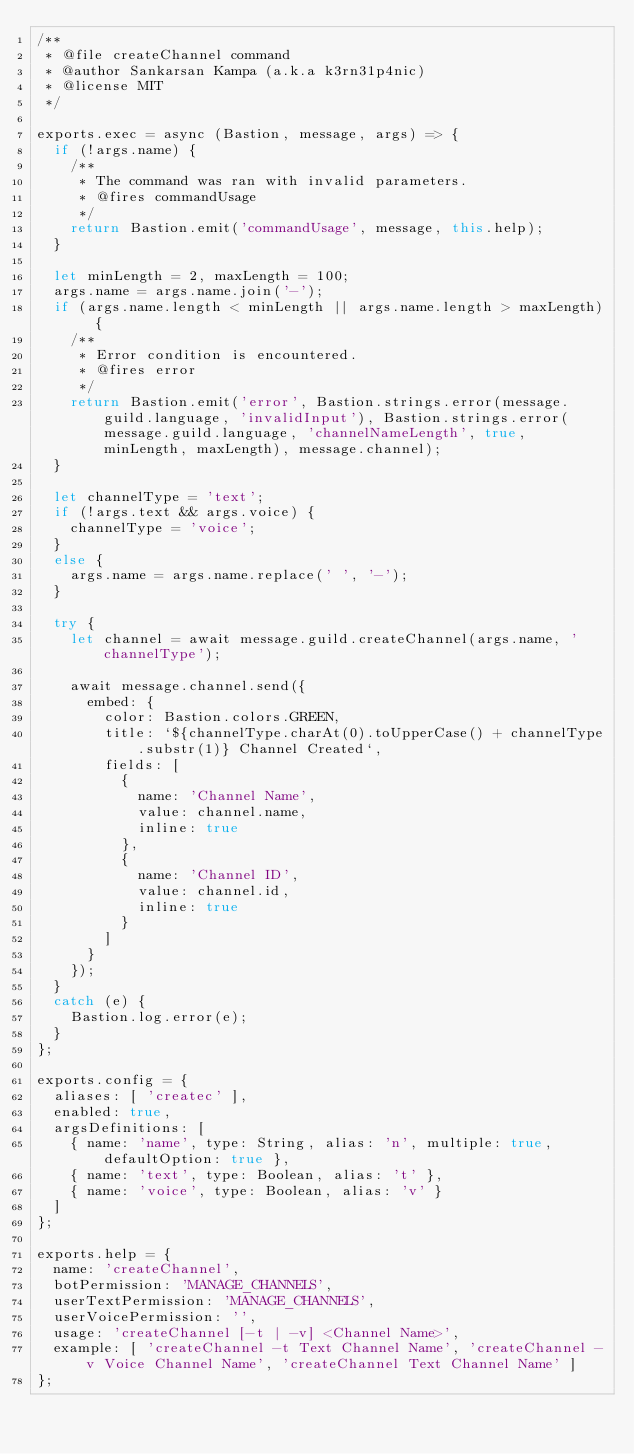<code> <loc_0><loc_0><loc_500><loc_500><_JavaScript_>/**
 * @file createChannel command
 * @author Sankarsan Kampa (a.k.a k3rn31p4nic)
 * @license MIT
 */

exports.exec = async (Bastion, message, args) => {
  if (!args.name) {
    /**
     * The command was ran with invalid parameters.
     * @fires commandUsage
     */
    return Bastion.emit('commandUsage', message, this.help);
  }

  let minLength = 2, maxLength = 100;
  args.name = args.name.join('-');
  if (args.name.length < minLength || args.name.length > maxLength) {
    /**
     * Error condition is encountered.
     * @fires error
     */
    return Bastion.emit('error', Bastion.strings.error(message.guild.language, 'invalidInput'), Bastion.strings.error(message.guild.language, 'channelNameLength', true, minLength, maxLength), message.channel);
  }

  let channelType = 'text';
  if (!args.text && args.voice) {
    channelType = 'voice';
  }
  else {
    args.name = args.name.replace(' ', '-');
  }

  try {
    let channel = await message.guild.createChannel(args.name, 'channelType');

    await message.channel.send({
      embed: {
        color: Bastion.colors.GREEN,
        title: `${channelType.charAt(0).toUpperCase() + channelType.substr(1)} Channel Created`,
        fields: [
          {
            name: 'Channel Name',
            value: channel.name,
            inline: true
          },
          {
            name: 'Channel ID',
            value: channel.id,
            inline: true
          }
        ]
      }
    });
  }
  catch (e) {
    Bastion.log.error(e);
  }
};

exports.config = {
  aliases: [ 'createc' ],
  enabled: true,
  argsDefinitions: [
    { name: 'name', type: String, alias: 'n', multiple: true, defaultOption: true },
    { name: 'text', type: Boolean, alias: 't' },
    { name: 'voice', type: Boolean, alias: 'v' }
  ]
};

exports.help = {
  name: 'createChannel',
  botPermission: 'MANAGE_CHANNELS',
  userTextPermission: 'MANAGE_CHANNELS',
  userVoicePermission: '',
  usage: 'createChannel [-t | -v] <Channel Name>',
  example: [ 'createChannel -t Text Channel Name', 'createChannel -v Voice Channel Name', 'createChannel Text Channel Name' ]
};
</code> 